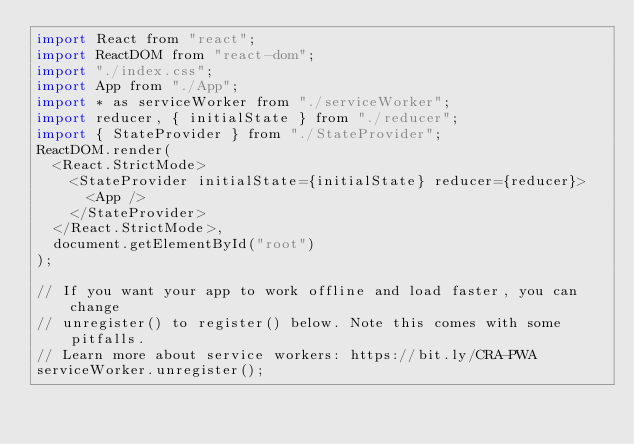Convert code to text. <code><loc_0><loc_0><loc_500><loc_500><_JavaScript_>import React from "react";
import ReactDOM from "react-dom";
import "./index.css";
import App from "./App";
import * as serviceWorker from "./serviceWorker";
import reducer, { initialState } from "./reducer";
import { StateProvider } from "./StateProvider";
ReactDOM.render(
  <React.StrictMode>
    <StateProvider initialState={initialState} reducer={reducer}>
      <App />
    </StateProvider>
  </React.StrictMode>,
  document.getElementById("root")
);

// If you want your app to work offline and load faster, you can change
// unregister() to register() below. Note this comes with some pitfalls.
// Learn more about service workers: https://bit.ly/CRA-PWA
serviceWorker.unregister();
</code> 